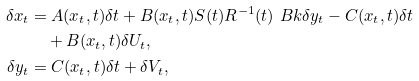<formula> <loc_0><loc_0><loc_500><loc_500>\delta x _ { t } & = A ( x _ { t } , t ) \delta t + B ( x _ { t } , t ) S ( t ) R ^ { - 1 } ( t ) \ B k { \delta y _ { t } - C ( x _ { t } , t ) \delta t } \\ & \quad + B ( x _ { t } , t ) \delta U _ { t } , \\ \delta y _ { t } & = C ( x _ { t } , t ) \delta t + \delta V _ { t } ,</formula> 